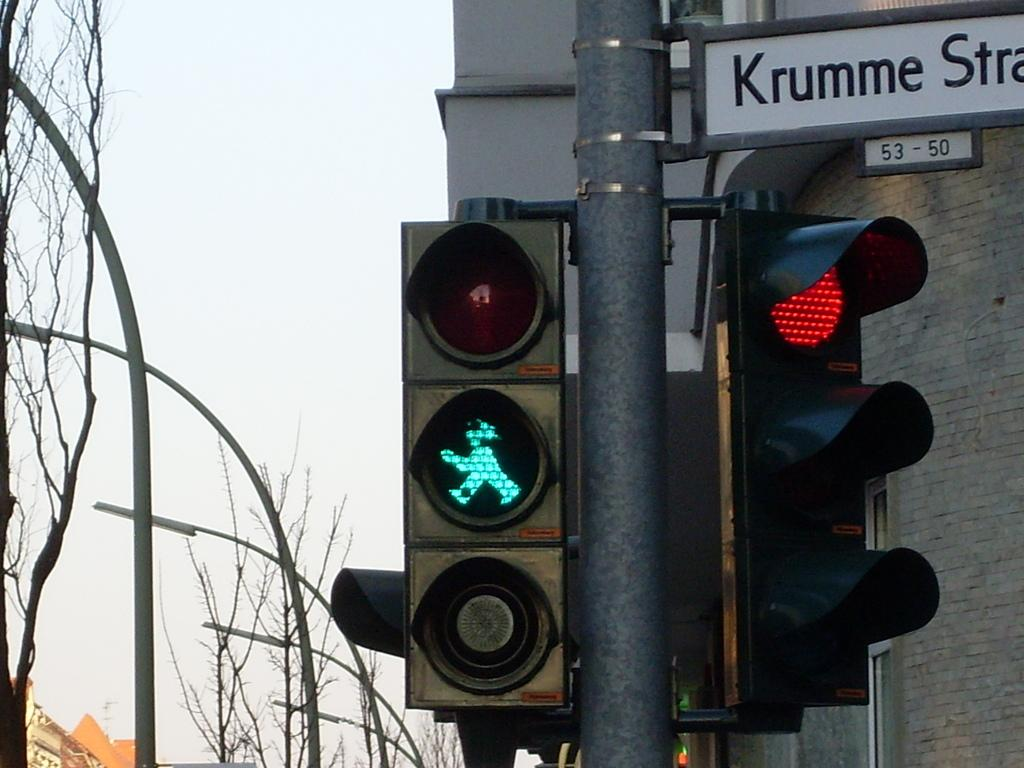<image>
Render a clear and concise summary of the photo. Traffic lights with the word Krumme visible on a sign. 